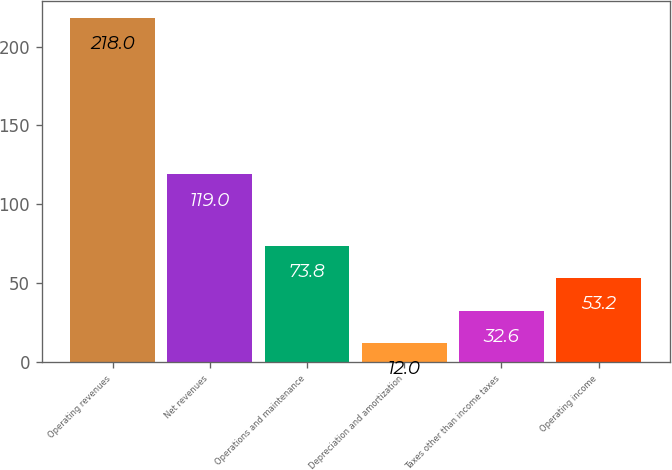Convert chart to OTSL. <chart><loc_0><loc_0><loc_500><loc_500><bar_chart><fcel>Operating revenues<fcel>Net revenues<fcel>Operations and maintenance<fcel>Depreciation and amortization<fcel>Taxes other than income taxes<fcel>Operating income<nl><fcel>218<fcel>119<fcel>73.8<fcel>12<fcel>32.6<fcel>53.2<nl></chart> 